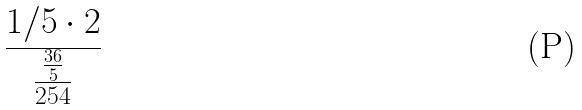<formula> <loc_0><loc_0><loc_500><loc_500>\frac { 1 / 5 \cdot 2 } { \frac { \frac { 3 6 } { 5 } } { 2 5 4 } }</formula> 